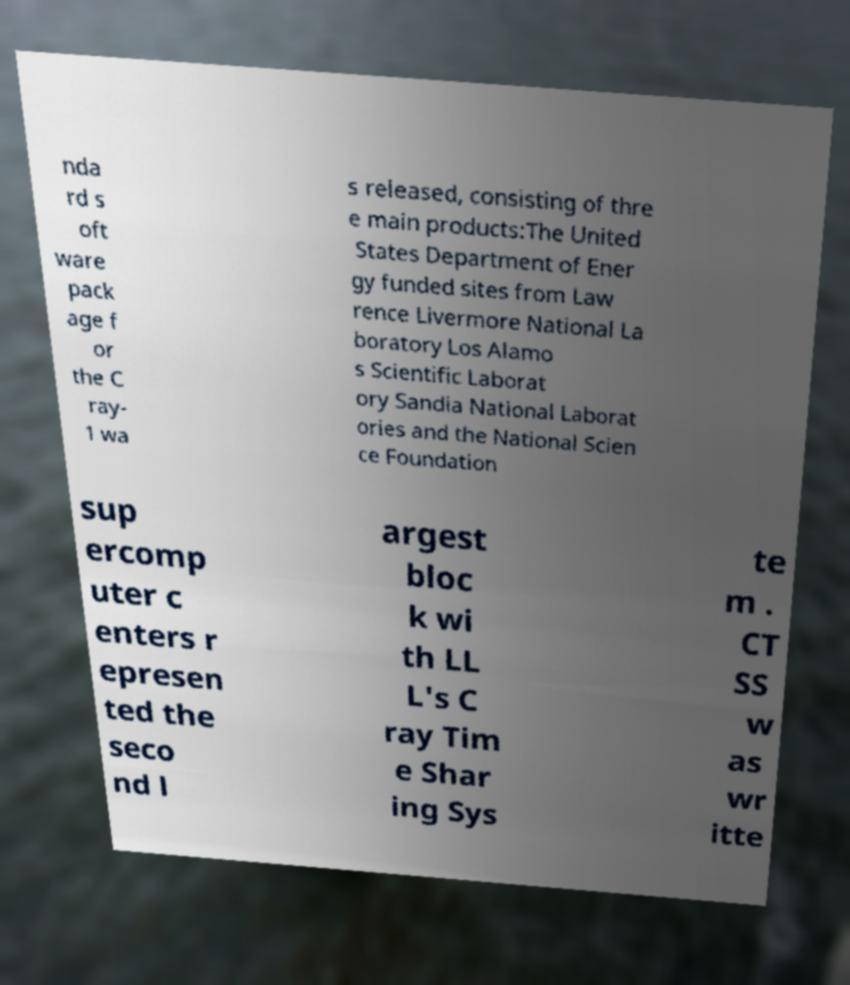Please identify and transcribe the text found in this image. nda rd s oft ware pack age f or the C ray- 1 wa s released, consisting of thre e main products:The United States Department of Ener gy funded sites from Law rence Livermore National La boratory Los Alamo s Scientific Laborat ory Sandia National Laborat ories and the National Scien ce Foundation sup ercomp uter c enters r epresen ted the seco nd l argest bloc k wi th LL L's C ray Tim e Shar ing Sys te m . CT SS w as wr itte 